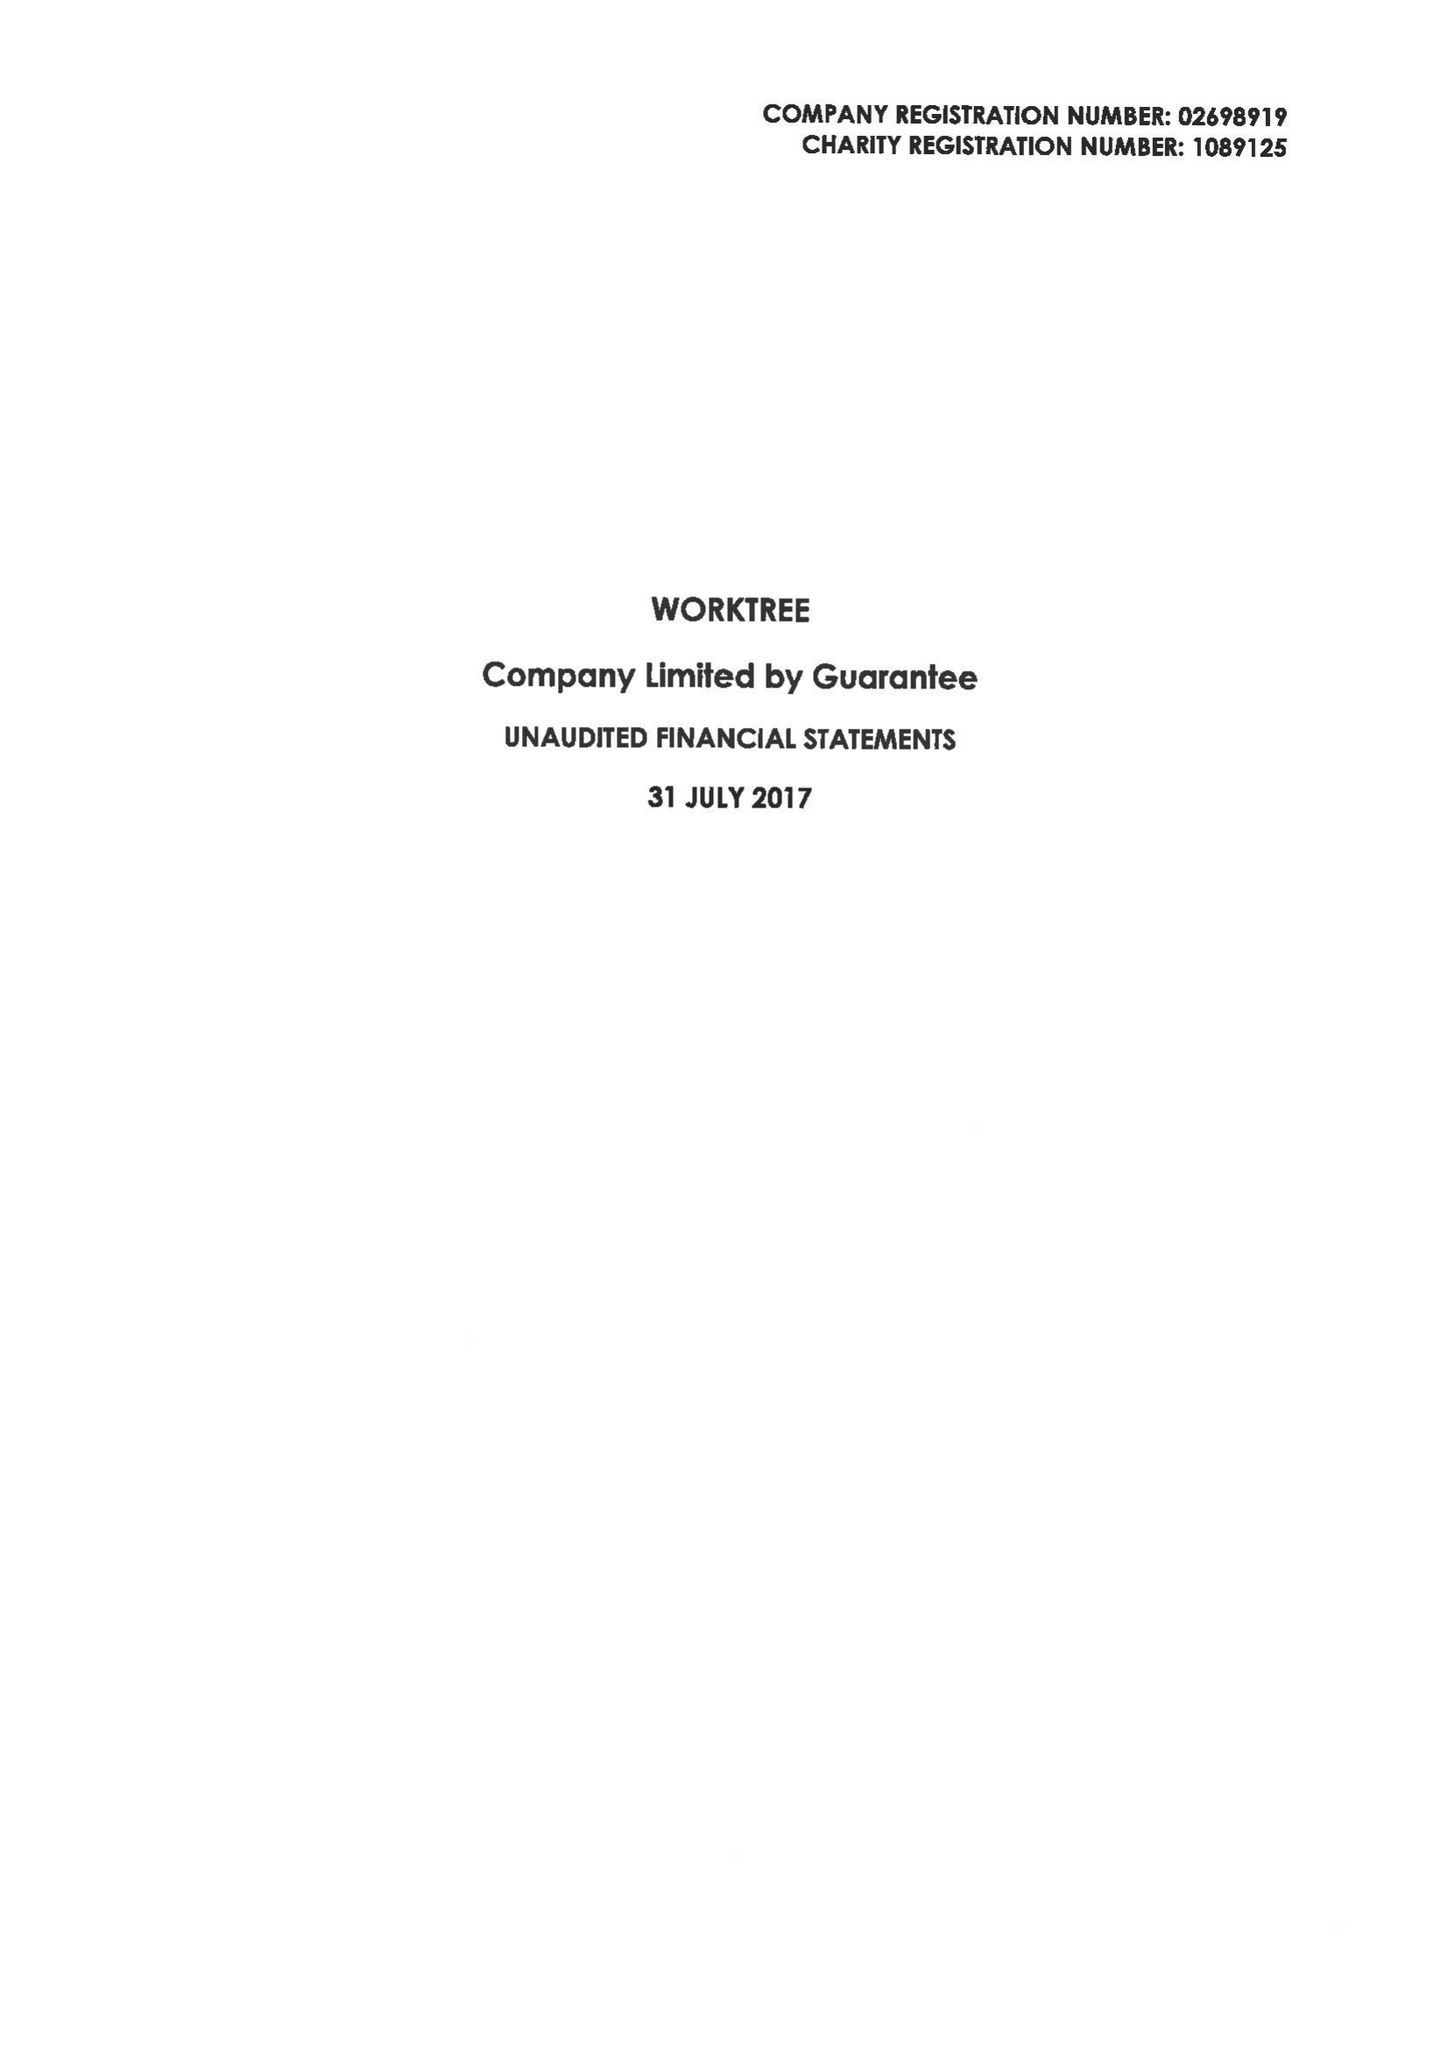What is the value for the charity_name?
Answer the question using a single word or phrase. Worktree 